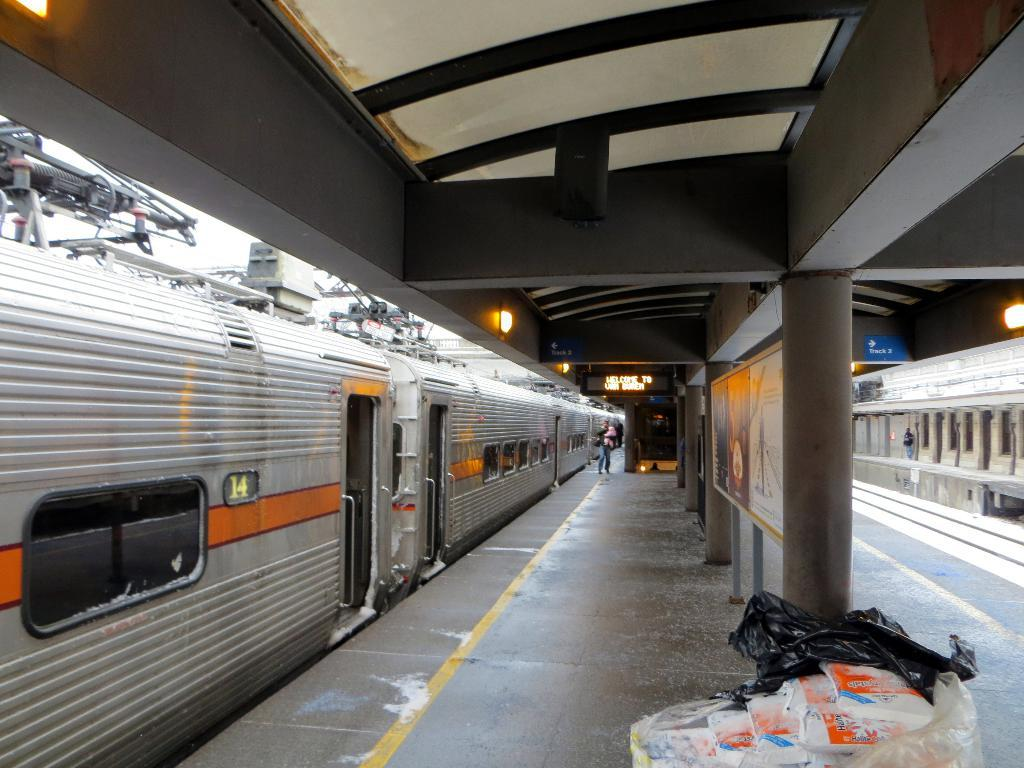What is located on the left side of the image? There is a train on the left side of the image. What can be seen in the center of the image? There is a train platform in the center of the image. What type of head injury can be seen on the train conductor in the image? There is no train conductor or head injury present in the image. What is the train conductor eating for breakfast in the image? There is no train conductor or breakfast present in the image. 